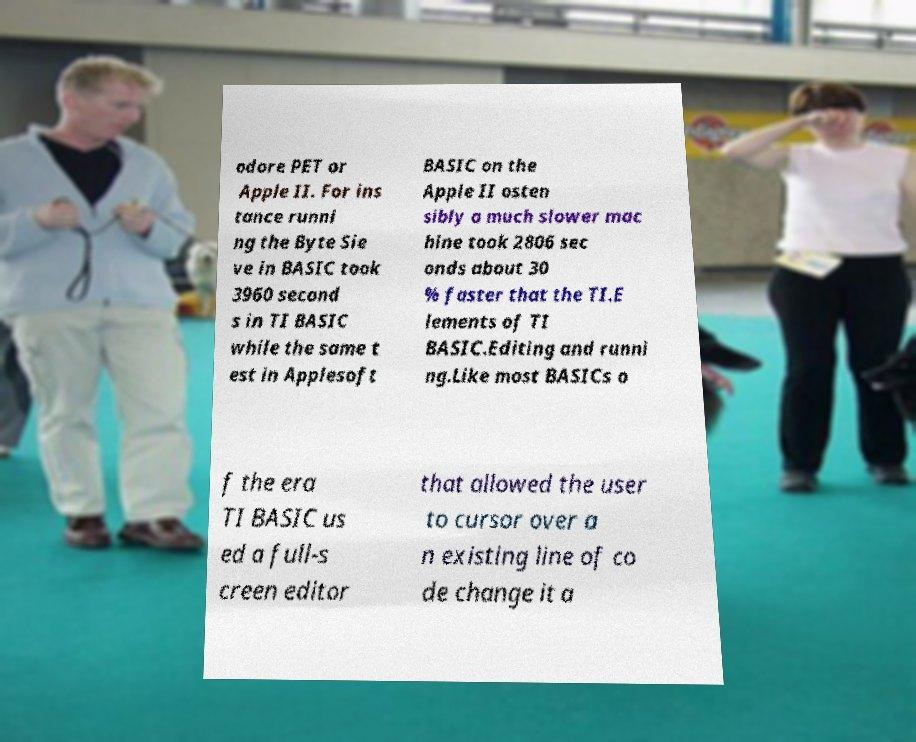Please read and relay the text visible in this image. What does it say? odore PET or Apple II. For ins tance runni ng the Byte Sie ve in BASIC took 3960 second s in TI BASIC while the same t est in Applesoft BASIC on the Apple II osten sibly a much slower mac hine took 2806 sec onds about 30 % faster that the TI.E lements of TI BASIC.Editing and runni ng.Like most BASICs o f the era TI BASIC us ed a full-s creen editor that allowed the user to cursor over a n existing line of co de change it a 